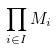<formula> <loc_0><loc_0><loc_500><loc_500>\prod _ { i \in I } M _ { i }</formula> 